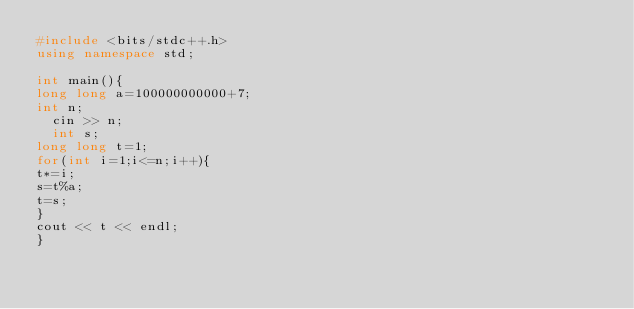<code> <loc_0><loc_0><loc_500><loc_500><_C++_>#include <bits/stdc++.h>
using namespace std;

int main(){
long long a=100000000000+7;
int n;
  cin >> n;
  int s;
long long t=1;
for(int i=1;i<=n;i++){
t*=i;
s=t%a;
t=s;  
} 
cout << t << endl;
}</code> 